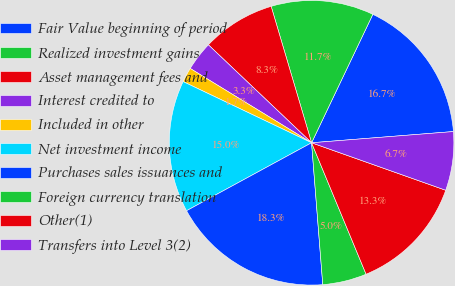<chart> <loc_0><loc_0><loc_500><loc_500><pie_chart><fcel>Fair Value beginning of period<fcel>Realized investment gains<fcel>Asset management fees and<fcel>Interest credited to<fcel>Included in other<fcel>Net investment income<fcel>Purchases sales issuances and<fcel>Foreign currency translation<fcel>Other(1)<fcel>Transfers into Level 3(2)<nl><fcel>16.66%<fcel>11.67%<fcel>8.33%<fcel>3.34%<fcel>1.67%<fcel>15.0%<fcel>18.33%<fcel>5.0%<fcel>13.33%<fcel>6.67%<nl></chart> 